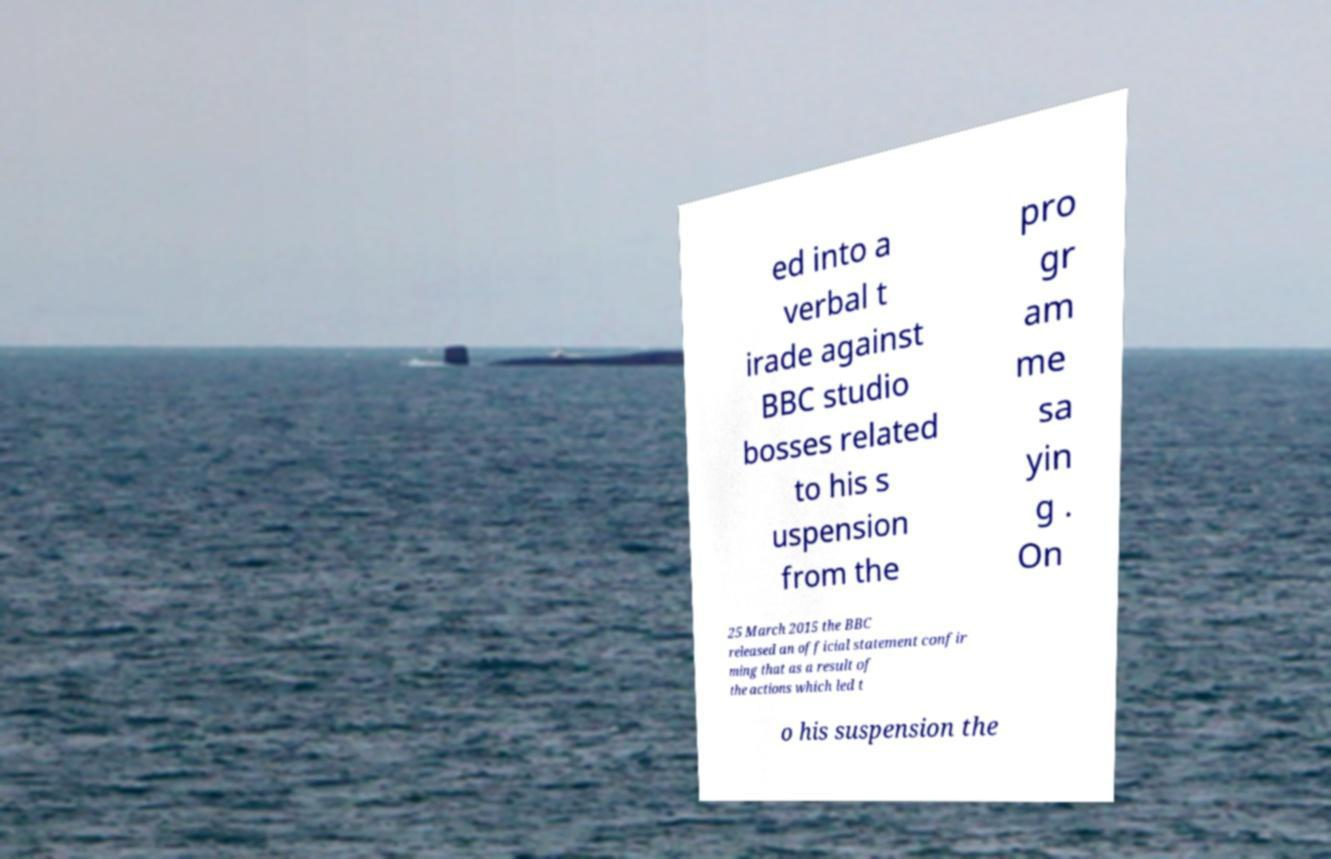Can you read and provide the text displayed in the image?This photo seems to have some interesting text. Can you extract and type it out for me? ed into a verbal t irade against BBC studio bosses related to his s uspension from the pro gr am me sa yin g . On 25 March 2015 the BBC released an official statement confir ming that as a result of the actions which led t o his suspension the 